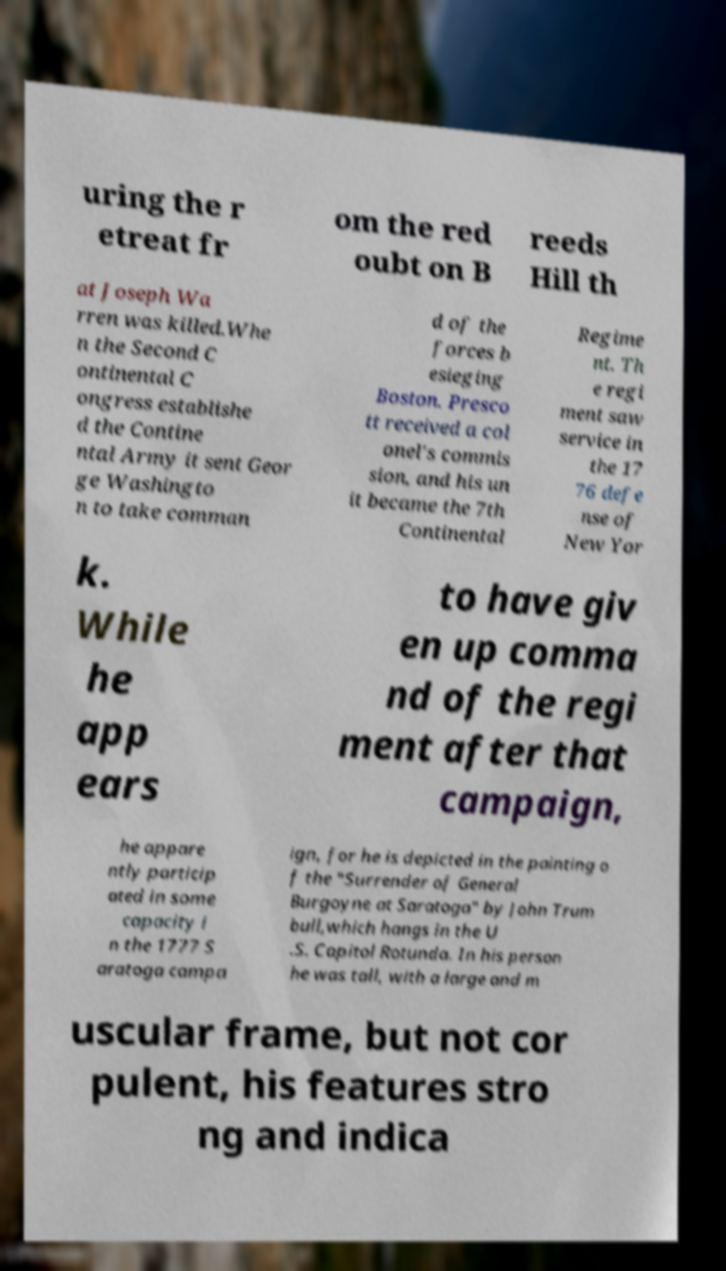Can you read and provide the text displayed in the image?This photo seems to have some interesting text. Can you extract and type it out for me? uring the r etreat fr om the red oubt on B reeds Hill th at Joseph Wa rren was killed.Whe n the Second C ontinental C ongress establishe d the Contine ntal Army it sent Geor ge Washingto n to take comman d of the forces b esieging Boston. Presco tt received a col onel's commis sion, and his un it became the 7th Continental Regime nt. Th e regi ment saw service in the 17 76 defe nse of New Yor k. While he app ears to have giv en up comma nd of the regi ment after that campaign, he appare ntly particip ated in some capacity i n the 1777 S aratoga campa ign, for he is depicted in the painting o f the "Surrender of General Burgoyne at Saratoga" by John Trum bull,which hangs in the U .S. Capitol Rotunda. In his person he was tall, with a large and m uscular frame, but not cor pulent, his features stro ng and indica 